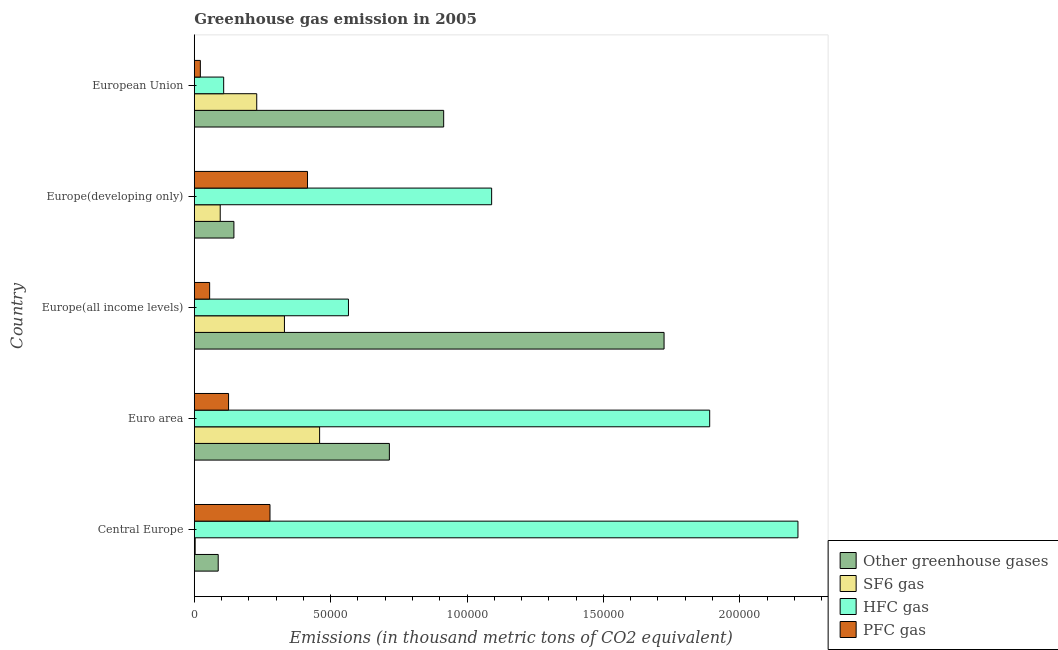Are the number of bars per tick equal to the number of legend labels?
Make the answer very short. Yes. How many bars are there on the 1st tick from the bottom?
Ensure brevity in your answer.  4. What is the label of the 5th group of bars from the top?
Provide a succinct answer. Central Europe. In how many cases, is the number of bars for a given country not equal to the number of legend labels?
Ensure brevity in your answer.  0. What is the emission of sf6 gas in Europe(all income levels)?
Make the answer very short. 3.31e+04. Across all countries, what is the maximum emission of sf6 gas?
Give a very brief answer. 4.60e+04. Across all countries, what is the minimum emission of sf6 gas?
Provide a succinct answer. 330.99. In which country was the emission of greenhouse gases maximum?
Your response must be concise. Europe(all income levels). In which country was the emission of sf6 gas minimum?
Ensure brevity in your answer.  Central Europe. What is the total emission of sf6 gas in the graph?
Your answer should be compact. 1.12e+05. What is the difference between the emission of pfc gas in Euro area and that in Europe(developing only)?
Offer a very short reply. -2.89e+04. What is the difference between the emission of hfc gas in Central Europe and the emission of greenhouse gases in Europe(all income levels)?
Offer a terse response. 4.91e+04. What is the average emission of pfc gas per country?
Provide a short and direct response. 1.79e+04. What is the difference between the emission of hfc gas and emission of sf6 gas in European Union?
Provide a short and direct response. -1.21e+04. In how many countries, is the emission of hfc gas greater than 50000 thousand metric tons?
Keep it short and to the point. 4. What is the ratio of the emission of hfc gas in Central Europe to that in European Union?
Give a very brief answer. 20.53. Is the difference between the emission of pfc gas in Euro area and European Union greater than the difference between the emission of sf6 gas in Euro area and European Union?
Make the answer very short. No. What is the difference between the highest and the second highest emission of sf6 gas?
Your answer should be very brief. 1.29e+04. What is the difference between the highest and the lowest emission of sf6 gas?
Your response must be concise. 4.56e+04. Is the sum of the emission of pfc gas in Euro area and Europe(all income levels) greater than the maximum emission of hfc gas across all countries?
Keep it short and to the point. No. Is it the case that in every country, the sum of the emission of sf6 gas and emission of pfc gas is greater than the sum of emission of hfc gas and emission of greenhouse gases?
Your response must be concise. No. What does the 4th bar from the top in Europe(developing only) represents?
Your answer should be compact. Other greenhouse gases. What does the 4th bar from the bottom in Central Europe represents?
Your response must be concise. PFC gas. Is it the case that in every country, the sum of the emission of greenhouse gases and emission of sf6 gas is greater than the emission of hfc gas?
Your answer should be compact. No. How many bars are there?
Keep it short and to the point. 20. What is the difference between two consecutive major ticks on the X-axis?
Give a very brief answer. 5.00e+04. Does the graph contain any zero values?
Your response must be concise. No. Does the graph contain grids?
Provide a short and direct response. No. Where does the legend appear in the graph?
Your answer should be very brief. Bottom right. What is the title of the graph?
Make the answer very short. Greenhouse gas emission in 2005. What is the label or title of the X-axis?
Give a very brief answer. Emissions (in thousand metric tons of CO2 equivalent). What is the label or title of the Y-axis?
Your answer should be very brief. Country. What is the Emissions (in thousand metric tons of CO2 equivalent) of Other greenhouse gases in Central Europe?
Your response must be concise. 8777.6. What is the Emissions (in thousand metric tons of CO2 equivalent) of SF6 gas in Central Europe?
Offer a terse response. 330.99. What is the Emissions (in thousand metric tons of CO2 equivalent) in HFC gas in Central Europe?
Offer a terse response. 2.21e+05. What is the Emissions (in thousand metric tons of CO2 equivalent) of PFC gas in Central Europe?
Offer a very short reply. 2.78e+04. What is the Emissions (in thousand metric tons of CO2 equivalent) in Other greenhouse gases in Euro area?
Offer a terse response. 7.15e+04. What is the Emissions (in thousand metric tons of CO2 equivalent) in SF6 gas in Euro area?
Ensure brevity in your answer.  4.60e+04. What is the Emissions (in thousand metric tons of CO2 equivalent) of HFC gas in Euro area?
Keep it short and to the point. 1.89e+05. What is the Emissions (in thousand metric tons of CO2 equivalent) in PFC gas in Euro area?
Offer a terse response. 1.26e+04. What is the Emissions (in thousand metric tons of CO2 equivalent) of Other greenhouse gases in Europe(all income levels)?
Keep it short and to the point. 1.72e+05. What is the Emissions (in thousand metric tons of CO2 equivalent) in SF6 gas in Europe(all income levels)?
Give a very brief answer. 3.31e+04. What is the Emissions (in thousand metric tons of CO2 equivalent) in HFC gas in Europe(all income levels)?
Offer a terse response. 5.65e+04. What is the Emissions (in thousand metric tons of CO2 equivalent) of PFC gas in Europe(all income levels)?
Keep it short and to the point. 5640.06. What is the Emissions (in thousand metric tons of CO2 equivalent) in Other greenhouse gases in Europe(developing only)?
Offer a very short reply. 1.45e+04. What is the Emissions (in thousand metric tons of CO2 equivalent) in SF6 gas in Europe(developing only)?
Ensure brevity in your answer.  9513.72. What is the Emissions (in thousand metric tons of CO2 equivalent) of HFC gas in Europe(developing only)?
Your answer should be compact. 1.09e+05. What is the Emissions (in thousand metric tons of CO2 equivalent) of PFC gas in Europe(developing only)?
Ensure brevity in your answer.  4.15e+04. What is the Emissions (in thousand metric tons of CO2 equivalent) in Other greenhouse gases in European Union?
Give a very brief answer. 9.14e+04. What is the Emissions (in thousand metric tons of CO2 equivalent) in SF6 gas in European Union?
Offer a terse response. 2.29e+04. What is the Emissions (in thousand metric tons of CO2 equivalent) of HFC gas in European Union?
Your response must be concise. 1.08e+04. What is the Emissions (in thousand metric tons of CO2 equivalent) in PFC gas in European Union?
Your answer should be compact. 2226.02. Across all countries, what is the maximum Emissions (in thousand metric tons of CO2 equivalent) of Other greenhouse gases?
Give a very brief answer. 1.72e+05. Across all countries, what is the maximum Emissions (in thousand metric tons of CO2 equivalent) in SF6 gas?
Ensure brevity in your answer.  4.60e+04. Across all countries, what is the maximum Emissions (in thousand metric tons of CO2 equivalent) of HFC gas?
Make the answer very short. 2.21e+05. Across all countries, what is the maximum Emissions (in thousand metric tons of CO2 equivalent) of PFC gas?
Your answer should be very brief. 4.15e+04. Across all countries, what is the minimum Emissions (in thousand metric tons of CO2 equivalent) in Other greenhouse gases?
Your answer should be very brief. 8777.6. Across all countries, what is the minimum Emissions (in thousand metric tons of CO2 equivalent) in SF6 gas?
Ensure brevity in your answer.  330.99. Across all countries, what is the minimum Emissions (in thousand metric tons of CO2 equivalent) of HFC gas?
Provide a succinct answer. 1.08e+04. Across all countries, what is the minimum Emissions (in thousand metric tons of CO2 equivalent) in PFC gas?
Ensure brevity in your answer.  2226.02. What is the total Emissions (in thousand metric tons of CO2 equivalent) of Other greenhouse gases in the graph?
Keep it short and to the point. 3.59e+05. What is the total Emissions (in thousand metric tons of CO2 equivalent) of SF6 gas in the graph?
Make the answer very short. 1.12e+05. What is the total Emissions (in thousand metric tons of CO2 equivalent) of HFC gas in the graph?
Your answer should be compact. 5.87e+05. What is the total Emissions (in thousand metric tons of CO2 equivalent) in PFC gas in the graph?
Provide a short and direct response. 8.97e+04. What is the difference between the Emissions (in thousand metric tons of CO2 equivalent) of Other greenhouse gases in Central Europe and that in Euro area?
Your response must be concise. -6.28e+04. What is the difference between the Emissions (in thousand metric tons of CO2 equivalent) in SF6 gas in Central Europe and that in Euro area?
Your response must be concise. -4.56e+04. What is the difference between the Emissions (in thousand metric tons of CO2 equivalent) of HFC gas in Central Europe and that in Euro area?
Your answer should be very brief. 3.24e+04. What is the difference between the Emissions (in thousand metric tons of CO2 equivalent) in PFC gas in Central Europe and that in Euro area?
Your answer should be compact. 1.52e+04. What is the difference between the Emissions (in thousand metric tons of CO2 equivalent) in Other greenhouse gases in Central Europe and that in Europe(all income levels)?
Your answer should be compact. -1.63e+05. What is the difference between the Emissions (in thousand metric tons of CO2 equivalent) of SF6 gas in Central Europe and that in Europe(all income levels)?
Give a very brief answer. -3.27e+04. What is the difference between the Emissions (in thousand metric tons of CO2 equivalent) of HFC gas in Central Europe and that in Europe(all income levels)?
Offer a very short reply. 1.65e+05. What is the difference between the Emissions (in thousand metric tons of CO2 equivalent) in PFC gas in Central Europe and that in Europe(all income levels)?
Ensure brevity in your answer.  2.21e+04. What is the difference between the Emissions (in thousand metric tons of CO2 equivalent) of Other greenhouse gases in Central Europe and that in Europe(developing only)?
Offer a terse response. -5756.5. What is the difference between the Emissions (in thousand metric tons of CO2 equivalent) in SF6 gas in Central Europe and that in Europe(developing only)?
Your answer should be compact. -9182.72. What is the difference between the Emissions (in thousand metric tons of CO2 equivalent) in HFC gas in Central Europe and that in Europe(developing only)?
Give a very brief answer. 1.12e+05. What is the difference between the Emissions (in thousand metric tons of CO2 equivalent) of PFC gas in Central Europe and that in Europe(developing only)?
Your answer should be compact. -1.38e+04. What is the difference between the Emissions (in thousand metric tons of CO2 equivalent) of Other greenhouse gases in Central Europe and that in European Union?
Keep it short and to the point. -8.27e+04. What is the difference between the Emissions (in thousand metric tons of CO2 equivalent) of SF6 gas in Central Europe and that in European Union?
Provide a short and direct response. -2.26e+04. What is the difference between the Emissions (in thousand metric tons of CO2 equivalent) in HFC gas in Central Europe and that in European Union?
Offer a terse response. 2.11e+05. What is the difference between the Emissions (in thousand metric tons of CO2 equivalent) in PFC gas in Central Europe and that in European Union?
Offer a terse response. 2.55e+04. What is the difference between the Emissions (in thousand metric tons of CO2 equivalent) of Other greenhouse gases in Euro area and that in Europe(all income levels)?
Your answer should be very brief. -1.01e+05. What is the difference between the Emissions (in thousand metric tons of CO2 equivalent) of SF6 gas in Euro area and that in Europe(all income levels)?
Make the answer very short. 1.29e+04. What is the difference between the Emissions (in thousand metric tons of CO2 equivalent) of HFC gas in Euro area and that in Europe(all income levels)?
Offer a terse response. 1.32e+05. What is the difference between the Emissions (in thousand metric tons of CO2 equivalent) in PFC gas in Euro area and that in Europe(all income levels)?
Make the answer very short. 6936.96. What is the difference between the Emissions (in thousand metric tons of CO2 equivalent) in Other greenhouse gases in Euro area and that in Europe(developing only)?
Make the answer very short. 5.70e+04. What is the difference between the Emissions (in thousand metric tons of CO2 equivalent) in SF6 gas in Euro area and that in Europe(developing only)?
Ensure brevity in your answer.  3.64e+04. What is the difference between the Emissions (in thousand metric tons of CO2 equivalent) of HFC gas in Euro area and that in Europe(developing only)?
Keep it short and to the point. 7.99e+04. What is the difference between the Emissions (in thousand metric tons of CO2 equivalent) in PFC gas in Euro area and that in Europe(developing only)?
Provide a succinct answer. -2.89e+04. What is the difference between the Emissions (in thousand metric tons of CO2 equivalent) in Other greenhouse gases in Euro area and that in European Union?
Your response must be concise. -1.99e+04. What is the difference between the Emissions (in thousand metric tons of CO2 equivalent) of SF6 gas in Euro area and that in European Union?
Keep it short and to the point. 2.31e+04. What is the difference between the Emissions (in thousand metric tons of CO2 equivalent) in HFC gas in Euro area and that in European Union?
Ensure brevity in your answer.  1.78e+05. What is the difference between the Emissions (in thousand metric tons of CO2 equivalent) of PFC gas in Euro area and that in European Union?
Offer a terse response. 1.04e+04. What is the difference between the Emissions (in thousand metric tons of CO2 equivalent) in Other greenhouse gases in Europe(all income levels) and that in Europe(developing only)?
Ensure brevity in your answer.  1.58e+05. What is the difference between the Emissions (in thousand metric tons of CO2 equivalent) of SF6 gas in Europe(all income levels) and that in Europe(developing only)?
Give a very brief answer. 2.35e+04. What is the difference between the Emissions (in thousand metric tons of CO2 equivalent) in HFC gas in Europe(all income levels) and that in Europe(developing only)?
Provide a short and direct response. -5.25e+04. What is the difference between the Emissions (in thousand metric tons of CO2 equivalent) in PFC gas in Europe(all income levels) and that in Europe(developing only)?
Keep it short and to the point. -3.59e+04. What is the difference between the Emissions (in thousand metric tons of CO2 equivalent) in Other greenhouse gases in Europe(all income levels) and that in European Union?
Give a very brief answer. 8.08e+04. What is the difference between the Emissions (in thousand metric tons of CO2 equivalent) of SF6 gas in Europe(all income levels) and that in European Union?
Your answer should be compact. 1.02e+04. What is the difference between the Emissions (in thousand metric tons of CO2 equivalent) in HFC gas in Europe(all income levels) and that in European Union?
Your answer should be very brief. 4.58e+04. What is the difference between the Emissions (in thousand metric tons of CO2 equivalent) in PFC gas in Europe(all income levels) and that in European Union?
Give a very brief answer. 3414.03. What is the difference between the Emissions (in thousand metric tons of CO2 equivalent) of Other greenhouse gases in Europe(developing only) and that in European Union?
Give a very brief answer. -7.69e+04. What is the difference between the Emissions (in thousand metric tons of CO2 equivalent) in SF6 gas in Europe(developing only) and that in European Union?
Your answer should be compact. -1.34e+04. What is the difference between the Emissions (in thousand metric tons of CO2 equivalent) of HFC gas in Europe(developing only) and that in European Union?
Ensure brevity in your answer.  9.82e+04. What is the difference between the Emissions (in thousand metric tons of CO2 equivalent) in PFC gas in Europe(developing only) and that in European Union?
Make the answer very short. 3.93e+04. What is the difference between the Emissions (in thousand metric tons of CO2 equivalent) of Other greenhouse gases in Central Europe and the Emissions (in thousand metric tons of CO2 equivalent) of SF6 gas in Euro area?
Offer a terse response. -3.72e+04. What is the difference between the Emissions (in thousand metric tons of CO2 equivalent) in Other greenhouse gases in Central Europe and the Emissions (in thousand metric tons of CO2 equivalent) in HFC gas in Euro area?
Offer a terse response. -1.80e+05. What is the difference between the Emissions (in thousand metric tons of CO2 equivalent) of Other greenhouse gases in Central Europe and the Emissions (in thousand metric tons of CO2 equivalent) of PFC gas in Euro area?
Provide a short and direct response. -3799.42. What is the difference between the Emissions (in thousand metric tons of CO2 equivalent) of SF6 gas in Central Europe and the Emissions (in thousand metric tons of CO2 equivalent) of HFC gas in Euro area?
Your answer should be compact. -1.89e+05. What is the difference between the Emissions (in thousand metric tons of CO2 equivalent) in SF6 gas in Central Europe and the Emissions (in thousand metric tons of CO2 equivalent) in PFC gas in Euro area?
Keep it short and to the point. -1.22e+04. What is the difference between the Emissions (in thousand metric tons of CO2 equivalent) in HFC gas in Central Europe and the Emissions (in thousand metric tons of CO2 equivalent) in PFC gas in Euro area?
Ensure brevity in your answer.  2.09e+05. What is the difference between the Emissions (in thousand metric tons of CO2 equivalent) in Other greenhouse gases in Central Europe and the Emissions (in thousand metric tons of CO2 equivalent) in SF6 gas in Europe(all income levels)?
Ensure brevity in your answer.  -2.43e+04. What is the difference between the Emissions (in thousand metric tons of CO2 equivalent) of Other greenhouse gases in Central Europe and the Emissions (in thousand metric tons of CO2 equivalent) of HFC gas in Europe(all income levels)?
Your answer should be compact. -4.78e+04. What is the difference between the Emissions (in thousand metric tons of CO2 equivalent) in Other greenhouse gases in Central Europe and the Emissions (in thousand metric tons of CO2 equivalent) in PFC gas in Europe(all income levels)?
Provide a succinct answer. 3137.54. What is the difference between the Emissions (in thousand metric tons of CO2 equivalent) of SF6 gas in Central Europe and the Emissions (in thousand metric tons of CO2 equivalent) of HFC gas in Europe(all income levels)?
Your response must be concise. -5.62e+04. What is the difference between the Emissions (in thousand metric tons of CO2 equivalent) of SF6 gas in Central Europe and the Emissions (in thousand metric tons of CO2 equivalent) of PFC gas in Europe(all income levels)?
Make the answer very short. -5309.06. What is the difference between the Emissions (in thousand metric tons of CO2 equivalent) of HFC gas in Central Europe and the Emissions (in thousand metric tons of CO2 equivalent) of PFC gas in Europe(all income levels)?
Provide a succinct answer. 2.16e+05. What is the difference between the Emissions (in thousand metric tons of CO2 equivalent) of Other greenhouse gases in Central Europe and the Emissions (in thousand metric tons of CO2 equivalent) of SF6 gas in Europe(developing only)?
Your response must be concise. -736.12. What is the difference between the Emissions (in thousand metric tons of CO2 equivalent) of Other greenhouse gases in Central Europe and the Emissions (in thousand metric tons of CO2 equivalent) of HFC gas in Europe(developing only)?
Your response must be concise. -1.00e+05. What is the difference between the Emissions (in thousand metric tons of CO2 equivalent) in Other greenhouse gases in Central Europe and the Emissions (in thousand metric tons of CO2 equivalent) in PFC gas in Europe(developing only)?
Offer a very short reply. -3.27e+04. What is the difference between the Emissions (in thousand metric tons of CO2 equivalent) in SF6 gas in Central Europe and the Emissions (in thousand metric tons of CO2 equivalent) in HFC gas in Europe(developing only)?
Offer a very short reply. -1.09e+05. What is the difference between the Emissions (in thousand metric tons of CO2 equivalent) of SF6 gas in Central Europe and the Emissions (in thousand metric tons of CO2 equivalent) of PFC gas in Europe(developing only)?
Provide a short and direct response. -4.12e+04. What is the difference between the Emissions (in thousand metric tons of CO2 equivalent) of HFC gas in Central Europe and the Emissions (in thousand metric tons of CO2 equivalent) of PFC gas in Europe(developing only)?
Your answer should be very brief. 1.80e+05. What is the difference between the Emissions (in thousand metric tons of CO2 equivalent) of Other greenhouse gases in Central Europe and the Emissions (in thousand metric tons of CO2 equivalent) of SF6 gas in European Union?
Offer a very short reply. -1.41e+04. What is the difference between the Emissions (in thousand metric tons of CO2 equivalent) in Other greenhouse gases in Central Europe and the Emissions (in thousand metric tons of CO2 equivalent) in HFC gas in European Union?
Offer a very short reply. -2001.13. What is the difference between the Emissions (in thousand metric tons of CO2 equivalent) in Other greenhouse gases in Central Europe and the Emissions (in thousand metric tons of CO2 equivalent) in PFC gas in European Union?
Provide a succinct answer. 6551.58. What is the difference between the Emissions (in thousand metric tons of CO2 equivalent) of SF6 gas in Central Europe and the Emissions (in thousand metric tons of CO2 equivalent) of HFC gas in European Union?
Your response must be concise. -1.04e+04. What is the difference between the Emissions (in thousand metric tons of CO2 equivalent) of SF6 gas in Central Europe and the Emissions (in thousand metric tons of CO2 equivalent) of PFC gas in European Union?
Provide a succinct answer. -1895.03. What is the difference between the Emissions (in thousand metric tons of CO2 equivalent) in HFC gas in Central Europe and the Emissions (in thousand metric tons of CO2 equivalent) in PFC gas in European Union?
Offer a very short reply. 2.19e+05. What is the difference between the Emissions (in thousand metric tons of CO2 equivalent) in Other greenhouse gases in Euro area and the Emissions (in thousand metric tons of CO2 equivalent) in SF6 gas in Europe(all income levels)?
Make the answer very short. 3.85e+04. What is the difference between the Emissions (in thousand metric tons of CO2 equivalent) of Other greenhouse gases in Euro area and the Emissions (in thousand metric tons of CO2 equivalent) of HFC gas in Europe(all income levels)?
Give a very brief answer. 1.50e+04. What is the difference between the Emissions (in thousand metric tons of CO2 equivalent) in Other greenhouse gases in Euro area and the Emissions (in thousand metric tons of CO2 equivalent) in PFC gas in Europe(all income levels)?
Ensure brevity in your answer.  6.59e+04. What is the difference between the Emissions (in thousand metric tons of CO2 equivalent) in SF6 gas in Euro area and the Emissions (in thousand metric tons of CO2 equivalent) in HFC gas in Europe(all income levels)?
Provide a succinct answer. -1.06e+04. What is the difference between the Emissions (in thousand metric tons of CO2 equivalent) in SF6 gas in Euro area and the Emissions (in thousand metric tons of CO2 equivalent) in PFC gas in Europe(all income levels)?
Give a very brief answer. 4.03e+04. What is the difference between the Emissions (in thousand metric tons of CO2 equivalent) of HFC gas in Euro area and the Emissions (in thousand metric tons of CO2 equivalent) of PFC gas in Europe(all income levels)?
Your response must be concise. 1.83e+05. What is the difference between the Emissions (in thousand metric tons of CO2 equivalent) of Other greenhouse gases in Euro area and the Emissions (in thousand metric tons of CO2 equivalent) of SF6 gas in Europe(developing only)?
Offer a terse response. 6.20e+04. What is the difference between the Emissions (in thousand metric tons of CO2 equivalent) in Other greenhouse gases in Euro area and the Emissions (in thousand metric tons of CO2 equivalent) in HFC gas in Europe(developing only)?
Offer a terse response. -3.75e+04. What is the difference between the Emissions (in thousand metric tons of CO2 equivalent) in Other greenhouse gases in Euro area and the Emissions (in thousand metric tons of CO2 equivalent) in PFC gas in Europe(developing only)?
Provide a succinct answer. 3.00e+04. What is the difference between the Emissions (in thousand metric tons of CO2 equivalent) of SF6 gas in Euro area and the Emissions (in thousand metric tons of CO2 equivalent) of HFC gas in Europe(developing only)?
Keep it short and to the point. -6.31e+04. What is the difference between the Emissions (in thousand metric tons of CO2 equivalent) of SF6 gas in Euro area and the Emissions (in thousand metric tons of CO2 equivalent) of PFC gas in Europe(developing only)?
Your answer should be very brief. 4433.97. What is the difference between the Emissions (in thousand metric tons of CO2 equivalent) of HFC gas in Euro area and the Emissions (in thousand metric tons of CO2 equivalent) of PFC gas in Europe(developing only)?
Offer a very short reply. 1.47e+05. What is the difference between the Emissions (in thousand metric tons of CO2 equivalent) in Other greenhouse gases in Euro area and the Emissions (in thousand metric tons of CO2 equivalent) in SF6 gas in European Union?
Your response must be concise. 4.86e+04. What is the difference between the Emissions (in thousand metric tons of CO2 equivalent) of Other greenhouse gases in Euro area and the Emissions (in thousand metric tons of CO2 equivalent) of HFC gas in European Union?
Keep it short and to the point. 6.08e+04. What is the difference between the Emissions (in thousand metric tons of CO2 equivalent) of Other greenhouse gases in Euro area and the Emissions (in thousand metric tons of CO2 equivalent) of PFC gas in European Union?
Offer a terse response. 6.93e+04. What is the difference between the Emissions (in thousand metric tons of CO2 equivalent) of SF6 gas in Euro area and the Emissions (in thousand metric tons of CO2 equivalent) of HFC gas in European Union?
Offer a very short reply. 3.52e+04. What is the difference between the Emissions (in thousand metric tons of CO2 equivalent) of SF6 gas in Euro area and the Emissions (in thousand metric tons of CO2 equivalent) of PFC gas in European Union?
Keep it short and to the point. 4.37e+04. What is the difference between the Emissions (in thousand metric tons of CO2 equivalent) of HFC gas in Euro area and the Emissions (in thousand metric tons of CO2 equivalent) of PFC gas in European Union?
Ensure brevity in your answer.  1.87e+05. What is the difference between the Emissions (in thousand metric tons of CO2 equivalent) of Other greenhouse gases in Europe(all income levels) and the Emissions (in thousand metric tons of CO2 equivalent) of SF6 gas in Europe(developing only)?
Offer a terse response. 1.63e+05. What is the difference between the Emissions (in thousand metric tons of CO2 equivalent) in Other greenhouse gases in Europe(all income levels) and the Emissions (in thousand metric tons of CO2 equivalent) in HFC gas in Europe(developing only)?
Your response must be concise. 6.32e+04. What is the difference between the Emissions (in thousand metric tons of CO2 equivalent) of Other greenhouse gases in Europe(all income levels) and the Emissions (in thousand metric tons of CO2 equivalent) of PFC gas in Europe(developing only)?
Provide a short and direct response. 1.31e+05. What is the difference between the Emissions (in thousand metric tons of CO2 equivalent) in SF6 gas in Europe(all income levels) and the Emissions (in thousand metric tons of CO2 equivalent) in HFC gas in Europe(developing only)?
Give a very brief answer. -7.60e+04. What is the difference between the Emissions (in thousand metric tons of CO2 equivalent) of SF6 gas in Europe(all income levels) and the Emissions (in thousand metric tons of CO2 equivalent) of PFC gas in Europe(developing only)?
Offer a very short reply. -8462.46. What is the difference between the Emissions (in thousand metric tons of CO2 equivalent) of HFC gas in Europe(all income levels) and the Emissions (in thousand metric tons of CO2 equivalent) of PFC gas in Europe(developing only)?
Offer a terse response. 1.50e+04. What is the difference between the Emissions (in thousand metric tons of CO2 equivalent) in Other greenhouse gases in Europe(all income levels) and the Emissions (in thousand metric tons of CO2 equivalent) in SF6 gas in European Union?
Keep it short and to the point. 1.49e+05. What is the difference between the Emissions (in thousand metric tons of CO2 equivalent) in Other greenhouse gases in Europe(all income levels) and the Emissions (in thousand metric tons of CO2 equivalent) in HFC gas in European Union?
Your response must be concise. 1.61e+05. What is the difference between the Emissions (in thousand metric tons of CO2 equivalent) in Other greenhouse gases in Europe(all income levels) and the Emissions (in thousand metric tons of CO2 equivalent) in PFC gas in European Union?
Ensure brevity in your answer.  1.70e+05. What is the difference between the Emissions (in thousand metric tons of CO2 equivalent) in SF6 gas in Europe(all income levels) and the Emissions (in thousand metric tons of CO2 equivalent) in HFC gas in European Union?
Offer a very short reply. 2.23e+04. What is the difference between the Emissions (in thousand metric tons of CO2 equivalent) of SF6 gas in Europe(all income levels) and the Emissions (in thousand metric tons of CO2 equivalent) of PFC gas in European Union?
Offer a terse response. 3.08e+04. What is the difference between the Emissions (in thousand metric tons of CO2 equivalent) in HFC gas in Europe(all income levels) and the Emissions (in thousand metric tons of CO2 equivalent) in PFC gas in European Union?
Offer a very short reply. 5.43e+04. What is the difference between the Emissions (in thousand metric tons of CO2 equivalent) in Other greenhouse gases in Europe(developing only) and the Emissions (in thousand metric tons of CO2 equivalent) in SF6 gas in European Union?
Your answer should be compact. -8366.71. What is the difference between the Emissions (in thousand metric tons of CO2 equivalent) of Other greenhouse gases in Europe(developing only) and the Emissions (in thousand metric tons of CO2 equivalent) of HFC gas in European Union?
Your response must be concise. 3755.37. What is the difference between the Emissions (in thousand metric tons of CO2 equivalent) in Other greenhouse gases in Europe(developing only) and the Emissions (in thousand metric tons of CO2 equivalent) in PFC gas in European Union?
Keep it short and to the point. 1.23e+04. What is the difference between the Emissions (in thousand metric tons of CO2 equivalent) of SF6 gas in Europe(developing only) and the Emissions (in thousand metric tons of CO2 equivalent) of HFC gas in European Union?
Provide a succinct answer. -1265.01. What is the difference between the Emissions (in thousand metric tons of CO2 equivalent) of SF6 gas in Europe(developing only) and the Emissions (in thousand metric tons of CO2 equivalent) of PFC gas in European Union?
Your answer should be compact. 7287.7. What is the difference between the Emissions (in thousand metric tons of CO2 equivalent) in HFC gas in Europe(developing only) and the Emissions (in thousand metric tons of CO2 equivalent) in PFC gas in European Union?
Your answer should be compact. 1.07e+05. What is the average Emissions (in thousand metric tons of CO2 equivalent) in Other greenhouse gases per country?
Provide a succinct answer. 7.17e+04. What is the average Emissions (in thousand metric tons of CO2 equivalent) of SF6 gas per country?
Your response must be concise. 2.24e+04. What is the average Emissions (in thousand metric tons of CO2 equivalent) of HFC gas per country?
Your answer should be very brief. 1.17e+05. What is the average Emissions (in thousand metric tons of CO2 equivalent) in PFC gas per country?
Ensure brevity in your answer.  1.79e+04. What is the difference between the Emissions (in thousand metric tons of CO2 equivalent) in Other greenhouse gases and Emissions (in thousand metric tons of CO2 equivalent) in SF6 gas in Central Europe?
Offer a very short reply. 8446.61. What is the difference between the Emissions (in thousand metric tons of CO2 equivalent) in Other greenhouse gases and Emissions (in thousand metric tons of CO2 equivalent) in HFC gas in Central Europe?
Your response must be concise. -2.13e+05. What is the difference between the Emissions (in thousand metric tons of CO2 equivalent) in Other greenhouse gases and Emissions (in thousand metric tons of CO2 equivalent) in PFC gas in Central Europe?
Provide a short and direct response. -1.90e+04. What is the difference between the Emissions (in thousand metric tons of CO2 equivalent) of SF6 gas and Emissions (in thousand metric tons of CO2 equivalent) of HFC gas in Central Europe?
Offer a terse response. -2.21e+05. What is the difference between the Emissions (in thousand metric tons of CO2 equivalent) of SF6 gas and Emissions (in thousand metric tons of CO2 equivalent) of PFC gas in Central Europe?
Your response must be concise. -2.74e+04. What is the difference between the Emissions (in thousand metric tons of CO2 equivalent) in HFC gas and Emissions (in thousand metric tons of CO2 equivalent) in PFC gas in Central Europe?
Give a very brief answer. 1.94e+05. What is the difference between the Emissions (in thousand metric tons of CO2 equivalent) in Other greenhouse gases and Emissions (in thousand metric tons of CO2 equivalent) in SF6 gas in Euro area?
Offer a terse response. 2.56e+04. What is the difference between the Emissions (in thousand metric tons of CO2 equivalent) of Other greenhouse gases and Emissions (in thousand metric tons of CO2 equivalent) of HFC gas in Euro area?
Offer a very short reply. -1.17e+05. What is the difference between the Emissions (in thousand metric tons of CO2 equivalent) in Other greenhouse gases and Emissions (in thousand metric tons of CO2 equivalent) in PFC gas in Euro area?
Provide a succinct answer. 5.90e+04. What is the difference between the Emissions (in thousand metric tons of CO2 equivalent) of SF6 gas and Emissions (in thousand metric tons of CO2 equivalent) of HFC gas in Euro area?
Provide a short and direct response. -1.43e+05. What is the difference between the Emissions (in thousand metric tons of CO2 equivalent) of SF6 gas and Emissions (in thousand metric tons of CO2 equivalent) of PFC gas in Euro area?
Your answer should be compact. 3.34e+04. What is the difference between the Emissions (in thousand metric tons of CO2 equivalent) of HFC gas and Emissions (in thousand metric tons of CO2 equivalent) of PFC gas in Euro area?
Ensure brevity in your answer.  1.76e+05. What is the difference between the Emissions (in thousand metric tons of CO2 equivalent) of Other greenhouse gases and Emissions (in thousand metric tons of CO2 equivalent) of SF6 gas in Europe(all income levels)?
Your answer should be compact. 1.39e+05. What is the difference between the Emissions (in thousand metric tons of CO2 equivalent) in Other greenhouse gases and Emissions (in thousand metric tons of CO2 equivalent) in HFC gas in Europe(all income levels)?
Keep it short and to the point. 1.16e+05. What is the difference between the Emissions (in thousand metric tons of CO2 equivalent) in Other greenhouse gases and Emissions (in thousand metric tons of CO2 equivalent) in PFC gas in Europe(all income levels)?
Your response must be concise. 1.67e+05. What is the difference between the Emissions (in thousand metric tons of CO2 equivalent) in SF6 gas and Emissions (in thousand metric tons of CO2 equivalent) in HFC gas in Europe(all income levels)?
Your response must be concise. -2.35e+04. What is the difference between the Emissions (in thousand metric tons of CO2 equivalent) of SF6 gas and Emissions (in thousand metric tons of CO2 equivalent) of PFC gas in Europe(all income levels)?
Offer a very short reply. 2.74e+04. What is the difference between the Emissions (in thousand metric tons of CO2 equivalent) of HFC gas and Emissions (in thousand metric tons of CO2 equivalent) of PFC gas in Europe(all income levels)?
Provide a succinct answer. 5.09e+04. What is the difference between the Emissions (in thousand metric tons of CO2 equivalent) in Other greenhouse gases and Emissions (in thousand metric tons of CO2 equivalent) in SF6 gas in Europe(developing only)?
Your answer should be very brief. 5020.38. What is the difference between the Emissions (in thousand metric tons of CO2 equivalent) of Other greenhouse gases and Emissions (in thousand metric tons of CO2 equivalent) of HFC gas in Europe(developing only)?
Give a very brief answer. -9.45e+04. What is the difference between the Emissions (in thousand metric tons of CO2 equivalent) of Other greenhouse gases and Emissions (in thousand metric tons of CO2 equivalent) of PFC gas in Europe(developing only)?
Ensure brevity in your answer.  -2.70e+04. What is the difference between the Emissions (in thousand metric tons of CO2 equivalent) of SF6 gas and Emissions (in thousand metric tons of CO2 equivalent) of HFC gas in Europe(developing only)?
Make the answer very short. -9.95e+04. What is the difference between the Emissions (in thousand metric tons of CO2 equivalent) of SF6 gas and Emissions (in thousand metric tons of CO2 equivalent) of PFC gas in Europe(developing only)?
Keep it short and to the point. -3.20e+04. What is the difference between the Emissions (in thousand metric tons of CO2 equivalent) of HFC gas and Emissions (in thousand metric tons of CO2 equivalent) of PFC gas in Europe(developing only)?
Ensure brevity in your answer.  6.75e+04. What is the difference between the Emissions (in thousand metric tons of CO2 equivalent) in Other greenhouse gases and Emissions (in thousand metric tons of CO2 equivalent) in SF6 gas in European Union?
Give a very brief answer. 6.85e+04. What is the difference between the Emissions (in thousand metric tons of CO2 equivalent) of Other greenhouse gases and Emissions (in thousand metric tons of CO2 equivalent) of HFC gas in European Union?
Provide a short and direct response. 8.07e+04. What is the difference between the Emissions (in thousand metric tons of CO2 equivalent) in Other greenhouse gases and Emissions (in thousand metric tons of CO2 equivalent) in PFC gas in European Union?
Ensure brevity in your answer.  8.92e+04. What is the difference between the Emissions (in thousand metric tons of CO2 equivalent) in SF6 gas and Emissions (in thousand metric tons of CO2 equivalent) in HFC gas in European Union?
Offer a terse response. 1.21e+04. What is the difference between the Emissions (in thousand metric tons of CO2 equivalent) of SF6 gas and Emissions (in thousand metric tons of CO2 equivalent) of PFC gas in European Union?
Offer a very short reply. 2.07e+04. What is the difference between the Emissions (in thousand metric tons of CO2 equivalent) of HFC gas and Emissions (in thousand metric tons of CO2 equivalent) of PFC gas in European Union?
Offer a terse response. 8552.71. What is the ratio of the Emissions (in thousand metric tons of CO2 equivalent) of Other greenhouse gases in Central Europe to that in Euro area?
Provide a succinct answer. 0.12. What is the ratio of the Emissions (in thousand metric tons of CO2 equivalent) of SF6 gas in Central Europe to that in Euro area?
Make the answer very short. 0.01. What is the ratio of the Emissions (in thousand metric tons of CO2 equivalent) in HFC gas in Central Europe to that in Euro area?
Offer a terse response. 1.17. What is the ratio of the Emissions (in thousand metric tons of CO2 equivalent) of PFC gas in Central Europe to that in Euro area?
Your answer should be very brief. 2.21. What is the ratio of the Emissions (in thousand metric tons of CO2 equivalent) of Other greenhouse gases in Central Europe to that in Europe(all income levels)?
Make the answer very short. 0.05. What is the ratio of the Emissions (in thousand metric tons of CO2 equivalent) of HFC gas in Central Europe to that in Europe(all income levels)?
Make the answer very short. 3.92. What is the ratio of the Emissions (in thousand metric tons of CO2 equivalent) in PFC gas in Central Europe to that in Europe(all income levels)?
Provide a succinct answer. 4.92. What is the ratio of the Emissions (in thousand metric tons of CO2 equivalent) in Other greenhouse gases in Central Europe to that in Europe(developing only)?
Provide a short and direct response. 0.6. What is the ratio of the Emissions (in thousand metric tons of CO2 equivalent) of SF6 gas in Central Europe to that in Europe(developing only)?
Your response must be concise. 0.03. What is the ratio of the Emissions (in thousand metric tons of CO2 equivalent) in HFC gas in Central Europe to that in Europe(developing only)?
Provide a succinct answer. 2.03. What is the ratio of the Emissions (in thousand metric tons of CO2 equivalent) in PFC gas in Central Europe to that in Europe(developing only)?
Provide a succinct answer. 0.67. What is the ratio of the Emissions (in thousand metric tons of CO2 equivalent) in Other greenhouse gases in Central Europe to that in European Union?
Give a very brief answer. 0.1. What is the ratio of the Emissions (in thousand metric tons of CO2 equivalent) in SF6 gas in Central Europe to that in European Union?
Offer a terse response. 0.01. What is the ratio of the Emissions (in thousand metric tons of CO2 equivalent) of HFC gas in Central Europe to that in European Union?
Offer a terse response. 20.53. What is the ratio of the Emissions (in thousand metric tons of CO2 equivalent) of PFC gas in Central Europe to that in European Union?
Keep it short and to the point. 12.47. What is the ratio of the Emissions (in thousand metric tons of CO2 equivalent) of Other greenhouse gases in Euro area to that in Europe(all income levels)?
Make the answer very short. 0.42. What is the ratio of the Emissions (in thousand metric tons of CO2 equivalent) in SF6 gas in Euro area to that in Europe(all income levels)?
Your response must be concise. 1.39. What is the ratio of the Emissions (in thousand metric tons of CO2 equivalent) in HFC gas in Euro area to that in Europe(all income levels)?
Keep it short and to the point. 3.34. What is the ratio of the Emissions (in thousand metric tons of CO2 equivalent) of PFC gas in Euro area to that in Europe(all income levels)?
Keep it short and to the point. 2.23. What is the ratio of the Emissions (in thousand metric tons of CO2 equivalent) of Other greenhouse gases in Euro area to that in Europe(developing only)?
Your answer should be very brief. 4.92. What is the ratio of the Emissions (in thousand metric tons of CO2 equivalent) of SF6 gas in Euro area to that in Europe(developing only)?
Your answer should be compact. 4.83. What is the ratio of the Emissions (in thousand metric tons of CO2 equivalent) in HFC gas in Euro area to that in Europe(developing only)?
Provide a succinct answer. 1.73. What is the ratio of the Emissions (in thousand metric tons of CO2 equivalent) in PFC gas in Euro area to that in Europe(developing only)?
Ensure brevity in your answer.  0.3. What is the ratio of the Emissions (in thousand metric tons of CO2 equivalent) of Other greenhouse gases in Euro area to that in European Union?
Ensure brevity in your answer.  0.78. What is the ratio of the Emissions (in thousand metric tons of CO2 equivalent) in SF6 gas in Euro area to that in European Union?
Your answer should be very brief. 2.01. What is the ratio of the Emissions (in thousand metric tons of CO2 equivalent) in HFC gas in Euro area to that in European Union?
Offer a very short reply. 17.53. What is the ratio of the Emissions (in thousand metric tons of CO2 equivalent) of PFC gas in Euro area to that in European Union?
Your answer should be compact. 5.65. What is the ratio of the Emissions (in thousand metric tons of CO2 equivalent) in Other greenhouse gases in Europe(all income levels) to that in Europe(developing only)?
Offer a very short reply. 11.85. What is the ratio of the Emissions (in thousand metric tons of CO2 equivalent) in SF6 gas in Europe(all income levels) to that in Europe(developing only)?
Ensure brevity in your answer.  3.47. What is the ratio of the Emissions (in thousand metric tons of CO2 equivalent) of HFC gas in Europe(all income levels) to that in Europe(developing only)?
Ensure brevity in your answer.  0.52. What is the ratio of the Emissions (in thousand metric tons of CO2 equivalent) in PFC gas in Europe(all income levels) to that in Europe(developing only)?
Offer a terse response. 0.14. What is the ratio of the Emissions (in thousand metric tons of CO2 equivalent) in Other greenhouse gases in Europe(all income levels) to that in European Union?
Offer a very short reply. 1.88. What is the ratio of the Emissions (in thousand metric tons of CO2 equivalent) of SF6 gas in Europe(all income levels) to that in European Union?
Your response must be concise. 1.44. What is the ratio of the Emissions (in thousand metric tons of CO2 equivalent) in HFC gas in Europe(all income levels) to that in European Union?
Offer a terse response. 5.24. What is the ratio of the Emissions (in thousand metric tons of CO2 equivalent) in PFC gas in Europe(all income levels) to that in European Union?
Make the answer very short. 2.53. What is the ratio of the Emissions (in thousand metric tons of CO2 equivalent) in Other greenhouse gases in Europe(developing only) to that in European Union?
Offer a very short reply. 0.16. What is the ratio of the Emissions (in thousand metric tons of CO2 equivalent) of SF6 gas in Europe(developing only) to that in European Union?
Make the answer very short. 0.42. What is the ratio of the Emissions (in thousand metric tons of CO2 equivalent) of HFC gas in Europe(developing only) to that in European Union?
Provide a succinct answer. 10.11. What is the ratio of the Emissions (in thousand metric tons of CO2 equivalent) of PFC gas in Europe(developing only) to that in European Union?
Offer a very short reply. 18.65. What is the difference between the highest and the second highest Emissions (in thousand metric tons of CO2 equivalent) of Other greenhouse gases?
Offer a very short reply. 8.08e+04. What is the difference between the highest and the second highest Emissions (in thousand metric tons of CO2 equivalent) of SF6 gas?
Offer a terse response. 1.29e+04. What is the difference between the highest and the second highest Emissions (in thousand metric tons of CO2 equivalent) of HFC gas?
Give a very brief answer. 3.24e+04. What is the difference between the highest and the second highest Emissions (in thousand metric tons of CO2 equivalent) of PFC gas?
Your answer should be compact. 1.38e+04. What is the difference between the highest and the lowest Emissions (in thousand metric tons of CO2 equivalent) of Other greenhouse gases?
Offer a terse response. 1.63e+05. What is the difference between the highest and the lowest Emissions (in thousand metric tons of CO2 equivalent) in SF6 gas?
Your answer should be compact. 4.56e+04. What is the difference between the highest and the lowest Emissions (in thousand metric tons of CO2 equivalent) in HFC gas?
Make the answer very short. 2.11e+05. What is the difference between the highest and the lowest Emissions (in thousand metric tons of CO2 equivalent) of PFC gas?
Provide a succinct answer. 3.93e+04. 